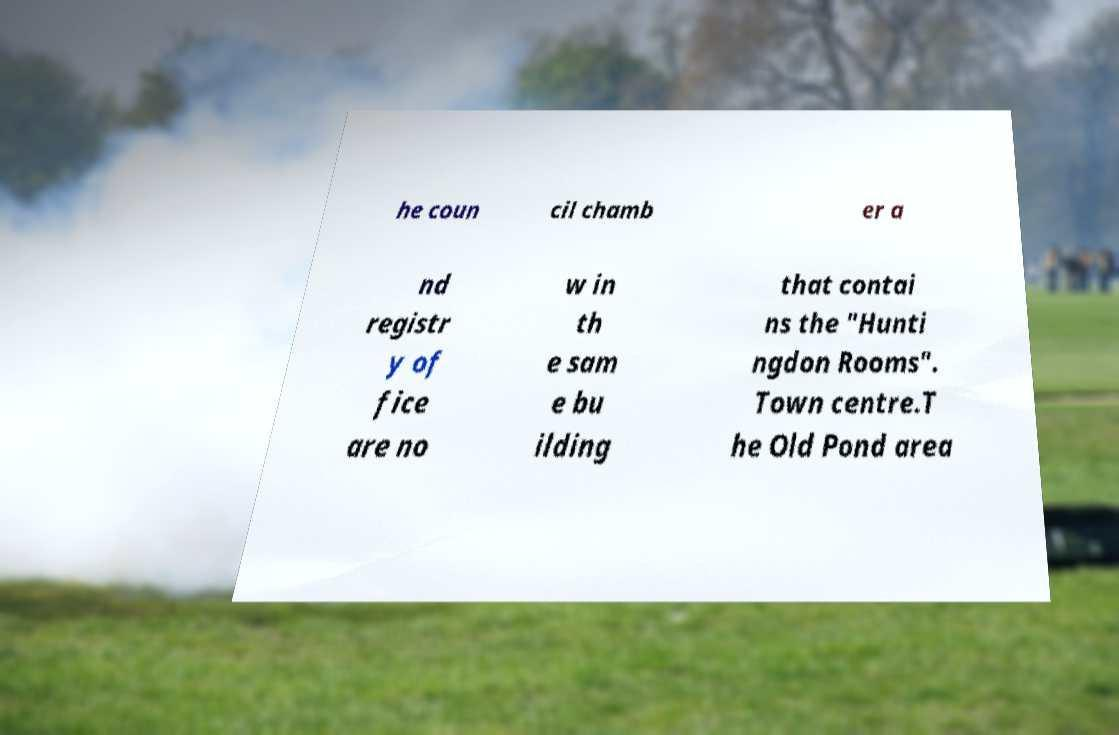Please identify and transcribe the text found in this image. he coun cil chamb er a nd registr y of fice are no w in th e sam e bu ilding that contai ns the "Hunti ngdon Rooms". Town centre.T he Old Pond area 